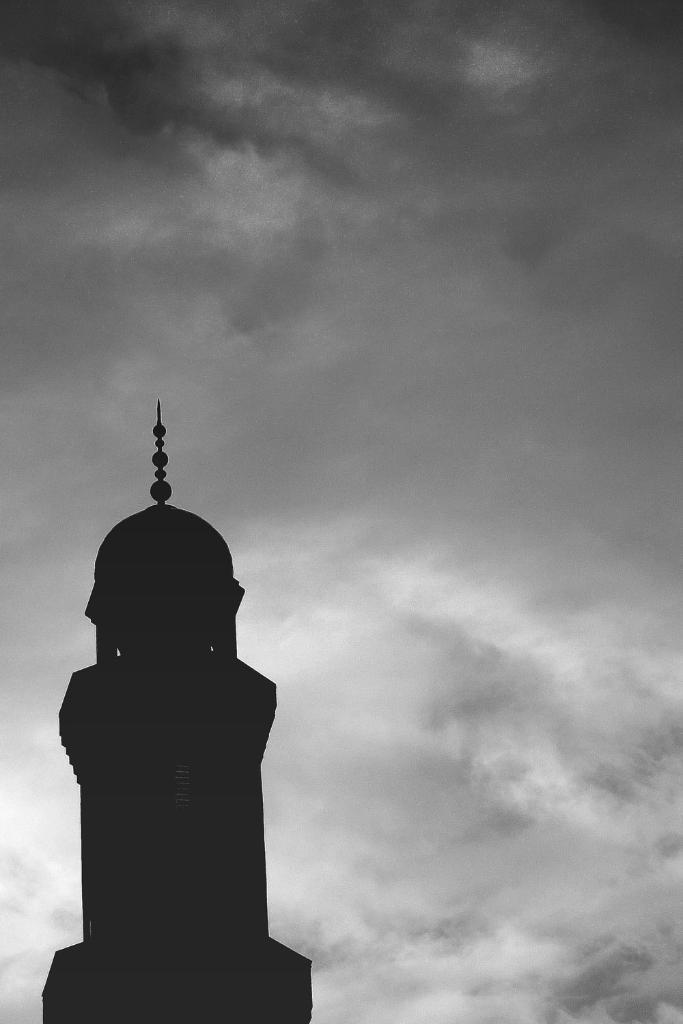Can you describe this image briefly? In this image in the front there is tower and in the background the sky is cloudy. 